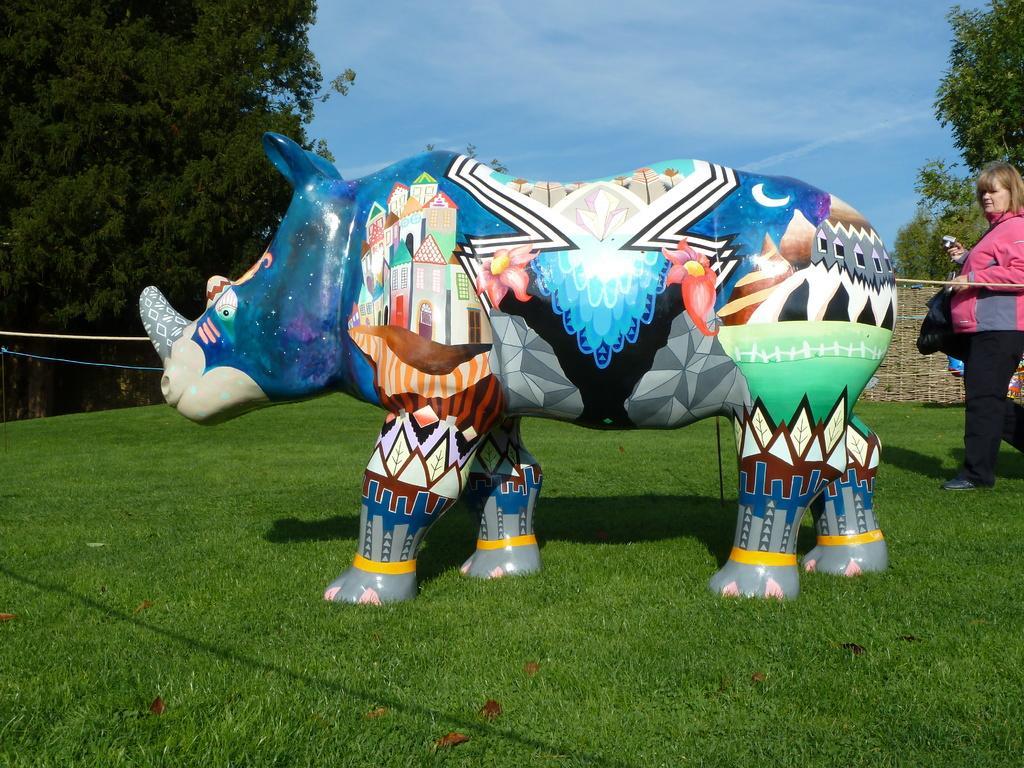Please provide a concise description of this image. In the picture we can see a grass surface on it, we can see a rhinoceros with some different paintings on it and besides it, we can see a woman standing and watching it and on the other sides of the grass path we can see plants, trees and in the background we can see a sky. 